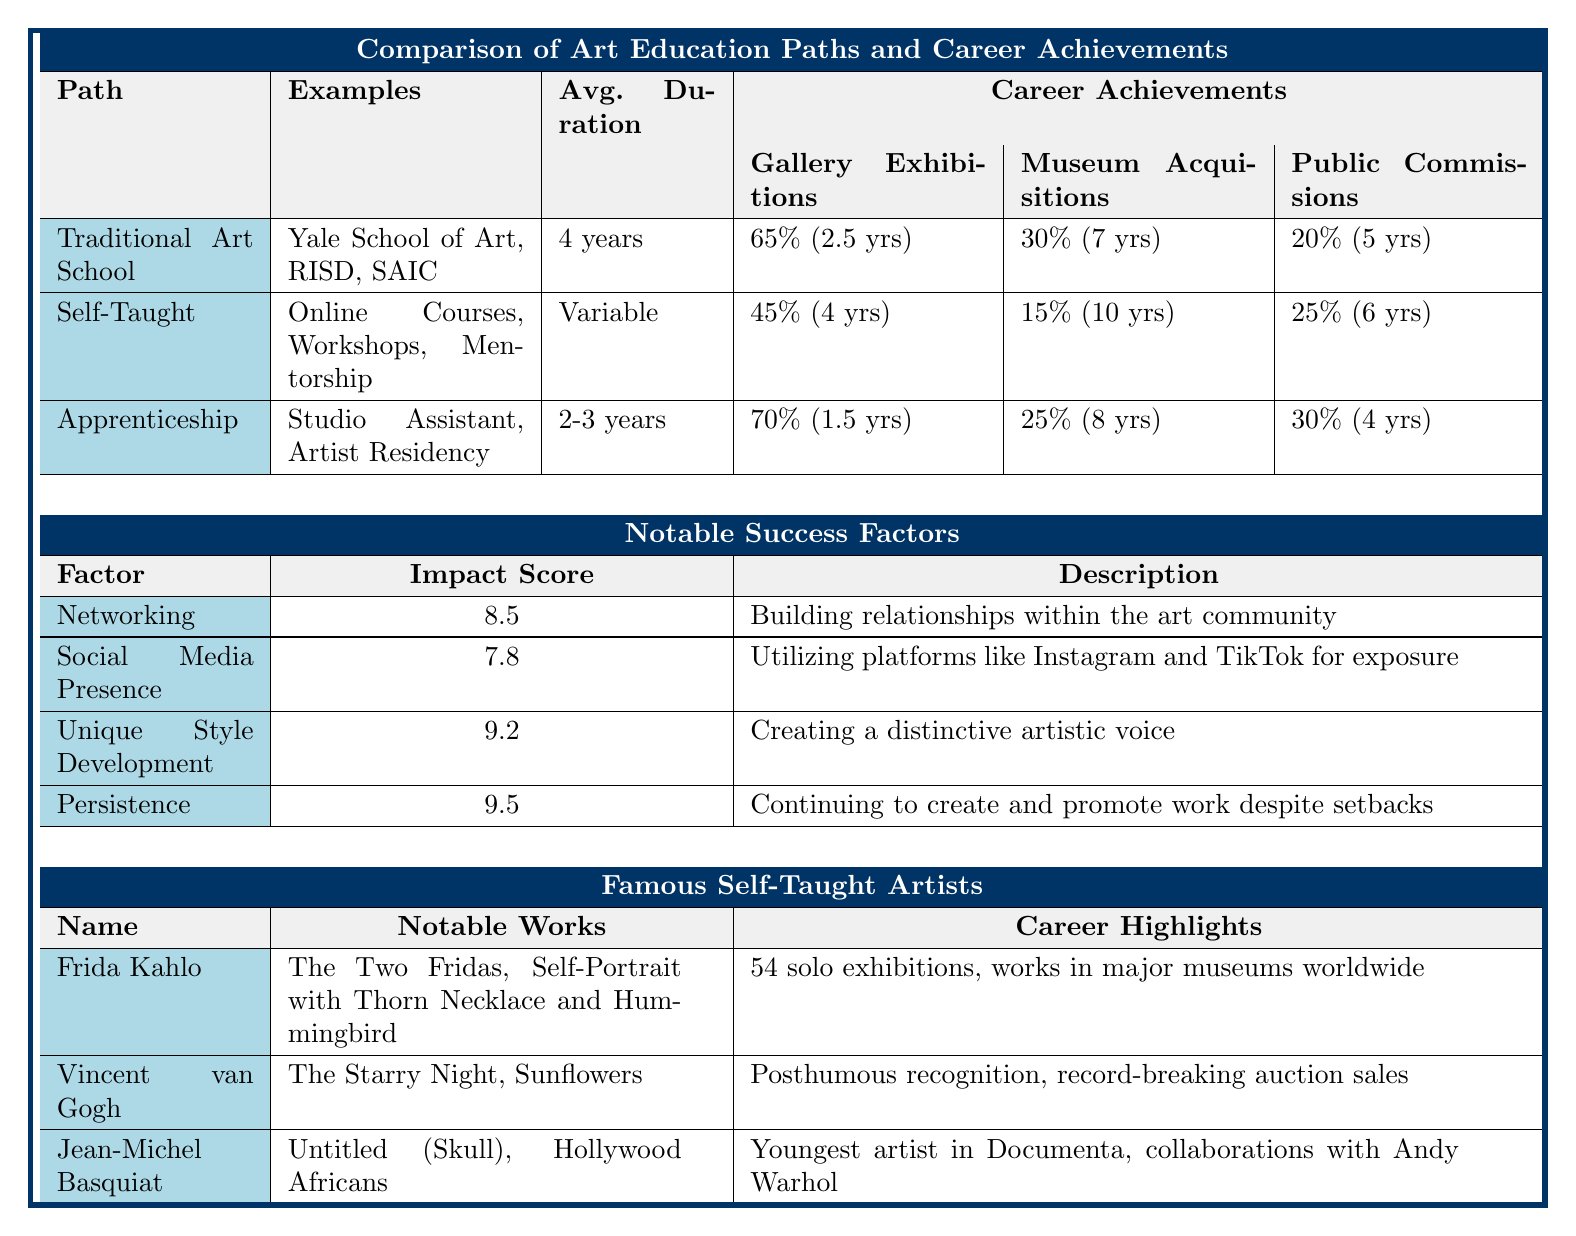What is the average program duration for the Traditional Art School path? The table states that the average program duration for the Traditional Art School path is 4 years.
Answer: 4 years Which art education path has the highest percentage of graduates achieving gallery exhibitions? According to the table, the Apprenticeship path has the highest percentage of graduates achieving gallery exhibitions at 70%.
Answer: Apprenticeship How long, on average, does it take for self-taught artists to have their first public commission? The table shows that self-taught artists average 6 years to obtain their first public commission.
Answer: 6 years Is it true that 30% of graduates from the Traditional Art School achieve museum acquisitions? The data indicates that 30% of Traditional Art School graduates indeed achieve museum acquisitions, making the statement true.
Answer: Yes What is the combined percentage of graduates from the Traditional Art School and Apprenticeship who obtain gallery exhibitions? The percentage of Traditional Art School graduates with gallery exhibitions is 65% and for Apprenticeship, it is 70%. Adding these gives 65 + 70 = 135%.
Answer: 135% Which notable success factor has the highest impact score? The highest impact score in the table is 9.5 for the factor Persistence.
Answer: 9.5 What is the average time to the first exhibition for graduates from the Apprenticeship path? According to the table, graduates from the Apprenticeship path have their first exhibition on average at 1.5 years.
Answer: 1.5 years How do the average times to first acquisition compare between Traditional Art School and Self-Taught paths? Traditional Art School graduates take an average of 7 years for their first acquisition, while Self-Taught graduates take 10 years. This means that Traditional Art School graduates achieve this milestone earlier.
Answer: Traditional Art School is earlier Which path has the lowest percentage of graduates achieving museum acquisitions? The Self-Taught path has the lowest percentage of graduates achieving museum acquisitions at 15%.
Answer: Self-Taught What is the difference in average time to first exhibition between graduates from the Traditional Art School and Apprenticeship? Traditional Art School graduates take 2.5 years, while Apprenticeship graduates take 1.5 years. The difference is 2.5 - 1.5 = 1 year, so Apprenticeship graduates achieve it 1 year sooner.
Answer: 1 year How many solo exhibitions did Frida Kahlo have? The data lists that Frida Kahlo had 54 solo exhibitions.
Answer: 54 solo exhibitions 